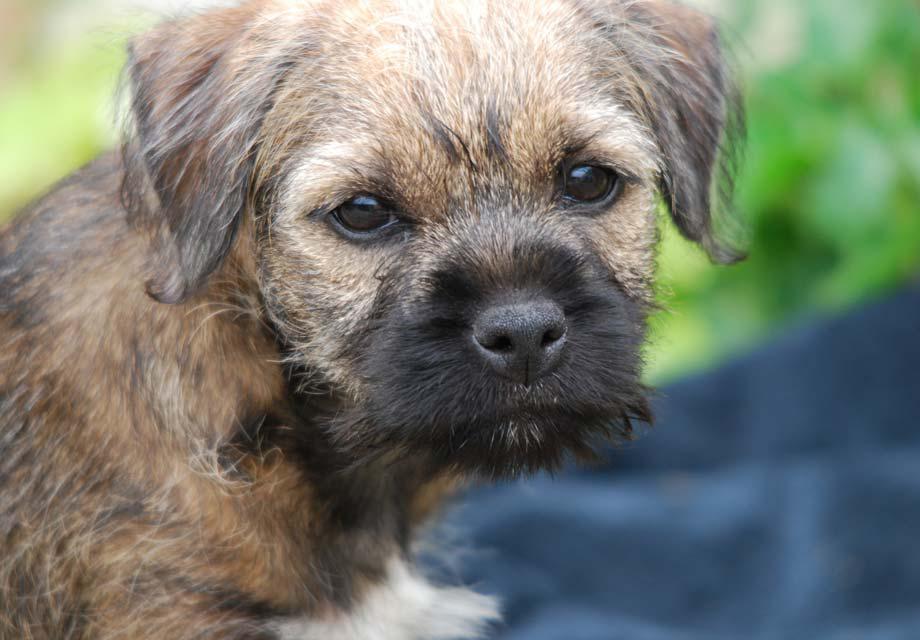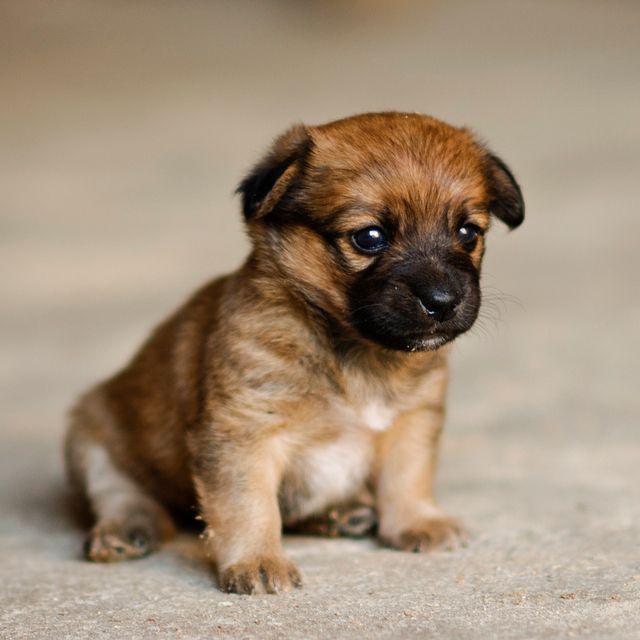The first image is the image on the left, the second image is the image on the right. Assess this claim about the two images: "At least one dog is standing on grass.". Correct or not? Answer yes or no. No. The first image is the image on the left, the second image is the image on the right. Given the left and right images, does the statement "A dog is standing in the grass with the paw on the left raised." hold true? Answer yes or no. No. 